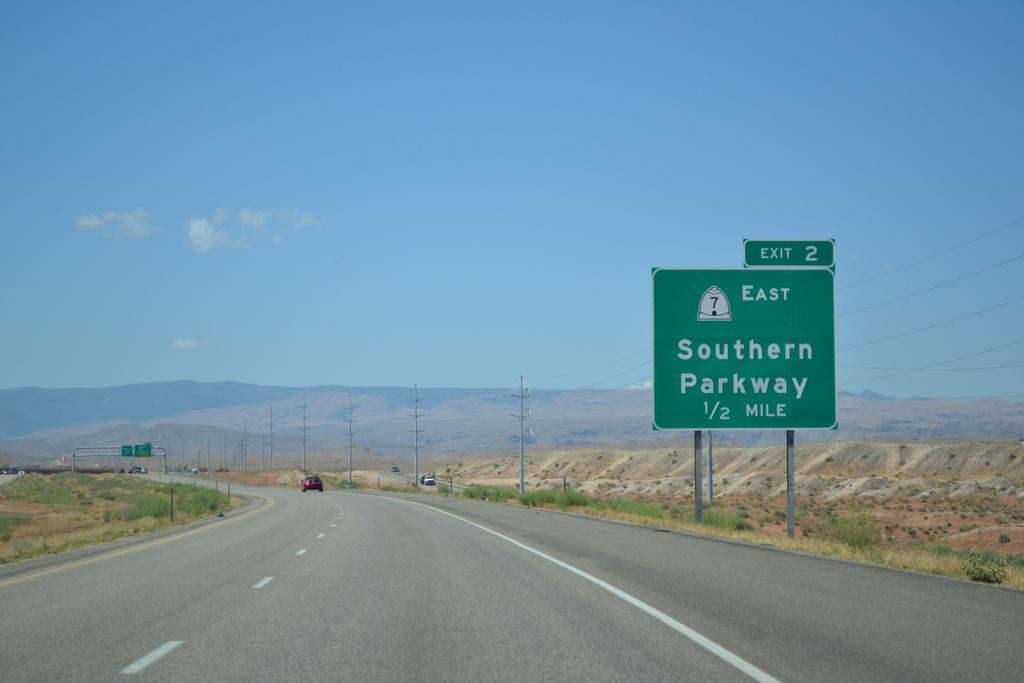Provide a one-sentence caption for the provided image. A green highway sign indicates Exit 2 and the Southern Parkway. 